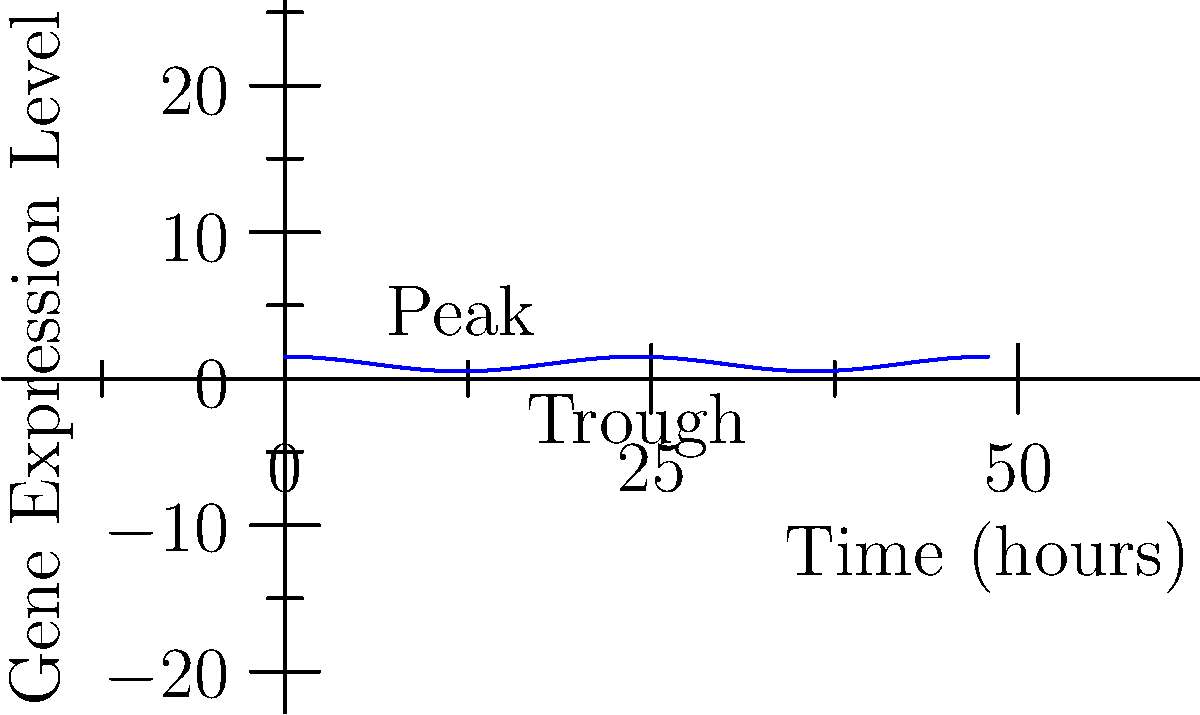The cosine function $f(t) = A \cos(\frac{2\pi}{P}t) + B$ is used to model the cyclic expression of a gene over time, where $A$ is the amplitude, $P$ is the period, and $B$ is the vertical shift. Given the graph showing gene expression levels over 48 hours, determine the period $P$ of this gene's expression cycle. To determine the period $P$ of the gene expression cycle, we need to analyze the graph:

1. The period is the time it takes for one complete cycle of the function.
2. In the graph, we can see that one complete cycle occurs between two consecutive peaks or troughs.
3. The first peak occurs at t = 12 hours.
4. The second peak occurs at t = 36 hours.
5. The time between these peaks is 36 - 12 = 24 hours.

Therefore, the period $P$ of this gene's expression cycle is 24 hours, which corresponds to a circadian rhythm.

This can be confirmed by looking at the equation of the cosine function:

$f(t) = A \cos(\frac{2\pi}{P}t) + B$

In this case, $\frac{2\pi}{P}t = \frac{2\pi}{24}t$, which simplifies to $\frac{\pi}{12}t$.
Answer: 24 hours 